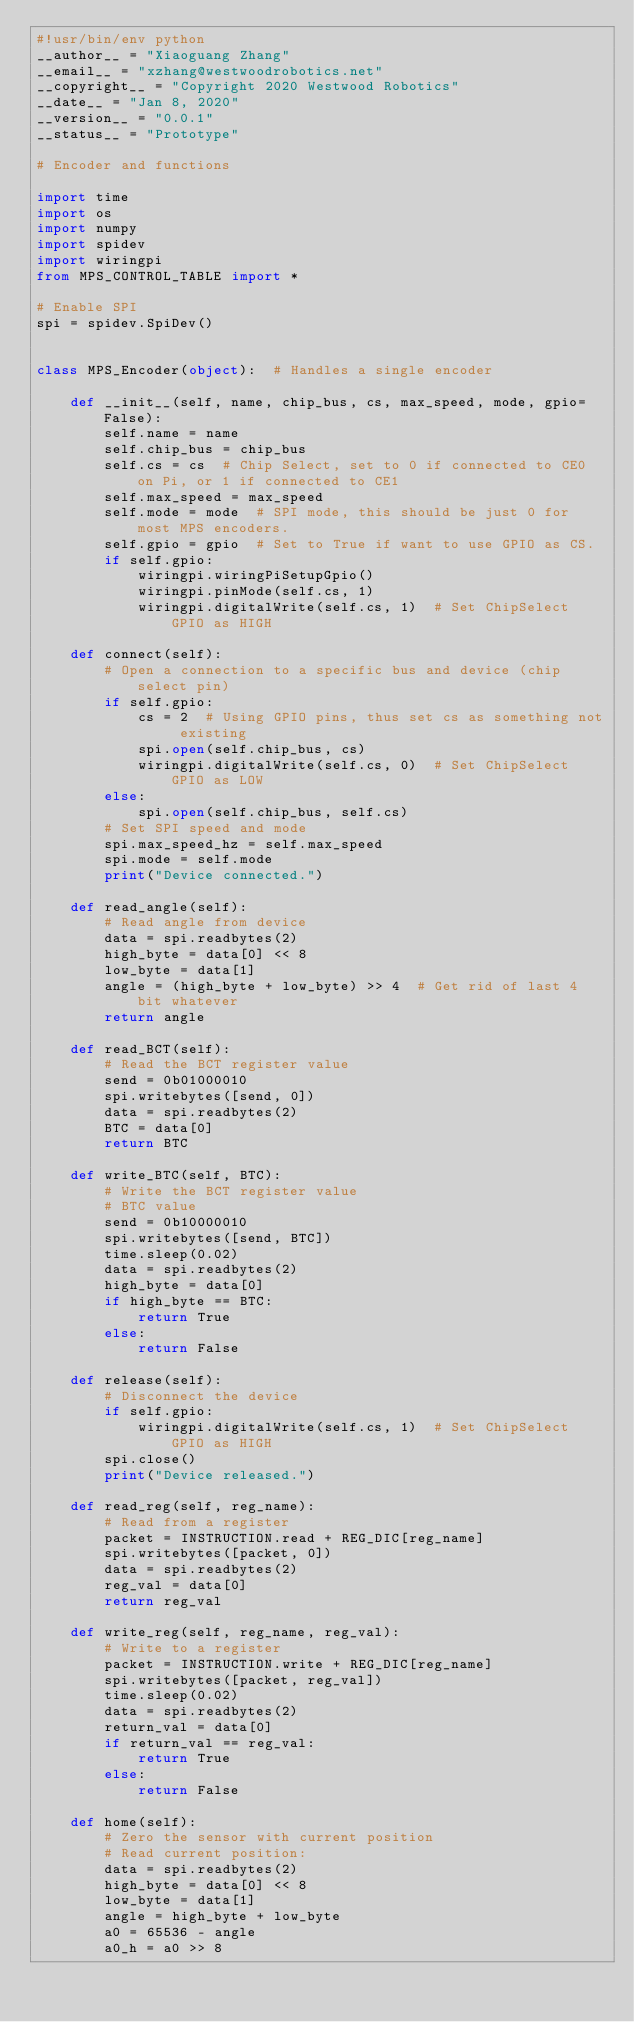<code> <loc_0><loc_0><loc_500><loc_500><_Python_>#!usr/bin/env python
__author__ = "Xiaoguang Zhang"
__email__ = "xzhang@westwoodrobotics.net"
__copyright__ = "Copyright 2020 Westwood Robotics"
__date__ = "Jan 8, 2020"
__version__ = "0.0.1"
__status__ = "Prototype"

# Encoder and functions

import time
import os
import numpy
import spidev
import wiringpi
from MPS_CONTROL_TABLE import *

# Enable SPI
spi = spidev.SpiDev()


class MPS_Encoder(object):  # Handles a single encoder

    def __init__(self, name, chip_bus, cs, max_speed, mode, gpio=False):
        self.name = name
        self.chip_bus = chip_bus
        self.cs = cs  # Chip Select, set to 0 if connected to CE0 on Pi, or 1 if connected to CE1
        self.max_speed = max_speed
        self.mode = mode  # SPI mode, this should be just 0 for most MPS encoders.
        self.gpio = gpio  # Set to True if want to use GPIO as CS.
        if self.gpio:
            wiringpi.wiringPiSetupGpio()
            wiringpi.pinMode(self.cs, 1)
            wiringpi.digitalWrite(self.cs, 1)  # Set ChipSelect GPIO as HIGH

    def connect(self):
        # Open a connection to a specific bus and device (chip select pin)
        if self.gpio:
            cs = 2  # Using GPIO pins, thus set cs as something not existing
            spi.open(self.chip_bus, cs)
            wiringpi.digitalWrite(self.cs, 0)  # Set ChipSelect GPIO as LOW
        else:
            spi.open(self.chip_bus, self.cs)
        # Set SPI speed and mode
        spi.max_speed_hz = self.max_speed
        spi.mode = self.mode
        print("Device connected.")

    def read_angle(self):
        # Read angle from device
        data = spi.readbytes(2)
        high_byte = data[0] << 8
        low_byte = data[1]
        angle = (high_byte + low_byte) >> 4  # Get rid of last 4 bit whatever
        return angle

    def read_BCT(self):
        # Read the BCT register value
        send = 0b01000010
        spi.writebytes([send, 0])
        data = spi.readbytes(2)
        BTC = data[0]
        return BTC

    def write_BTC(self, BTC):
        # Write the BCT register value
        # BTC value
        send = 0b10000010
        spi.writebytes([send, BTC])
        time.sleep(0.02)
        data = spi.readbytes(2)
        high_byte = data[0]
        if high_byte == BTC:
            return True
        else:
            return False

    def release(self):
        # Disconnect the device
        if self.gpio:
            wiringpi.digitalWrite(self.cs, 1)  # Set ChipSelect GPIO as HIGH
        spi.close()
        print("Device released.")

    def read_reg(self, reg_name):
        # Read from a register
        packet = INSTRUCTION.read + REG_DIC[reg_name]
        spi.writebytes([packet, 0])
        data = spi.readbytes(2)
        reg_val = data[0]
        return reg_val

    def write_reg(self, reg_name, reg_val):
        # Write to a register
        packet = INSTRUCTION.write + REG_DIC[reg_name]
        spi.writebytes([packet, reg_val])
        time.sleep(0.02)
        data = spi.readbytes(2)
        return_val = data[0]
        if return_val == reg_val:
            return True
        else:
            return False
        
    def home(self):
        # Zero the sensor with current position
        # Read current position:
        data = spi.readbytes(2)
        high_byte = data[0] << 8
        low_byte = data[1]
        angle = high_byte + low_byte  
        a0 = 65536 - angle
        a0_h = a0 >> 8</code> 